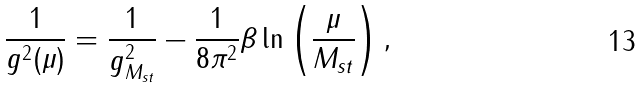<formula> <loc_0><loc_0><loc_500><loc_500>\frac { 1 } { g ^ { 2 } ( \mu ) } = \frac { 1 } { g ^ { 2 } _ { M _ { s t } } } - \frac { 1 } { 8 \pi ^ { 2 } } \beta \ln \left ( \frac { \mu } { M _ { s t } } \right ) ,</formula> 